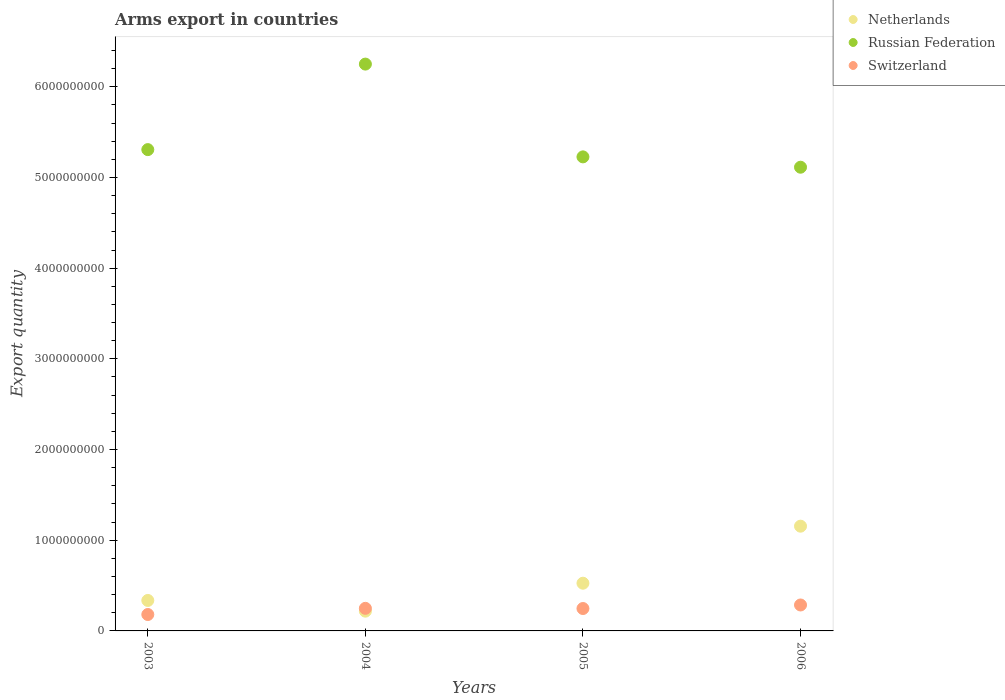What is the total arms export in Switzerland in 2005?
Ensure brevity in your answer.  2.47e+08. Across all years, what is the maximum total arms export in Switzerland?
Provide a short and direct response. 2.86e+08. Across all years, what is the minimum total arms export in Russian Federation?
Provide a succinct answer. 5.11e+09. In which year was the total arms export in Switzerland minimum?
Provide a short and direct response. 2003. What is the total total arms export in Russian Federation in the graph?
Offer a very short reply. 2.19e+1. What is the difference between the total arms export in Netherlands in 2004 and that in 2005?
Ensure brevity in your answer.  -3.08e+08. What is the difference between the total arms export in Netherlands in 2004 and the total arms export in Russian Federation in 2005?
Give a very brief answer. -5.01e+09. What is the average total arms export in Switzerland per year?
Make the answer very short. 2.41e+08. In the year 2004, what is the difference between the total arms export in Russian Federation and total arms export in Netherlands?
Make the answer very short. 6.03e+09. What is the ratio of the total arms export in Switzerland in 2004 to that in 2005?
Your response must be concise. 1.01. Is the difference between the total arms export in Russian Federation in 2003 and 2004 greater than the difference between the total arms export in Netherlands in 2003 and 2004?
Give a very brief answer. No. What is the difference between the highest and the second highest total arms export in Russian Federation?
Ensure brevity in your answer.  9.43e+08. What is the difference between the highest and the lowest total arms export in Netherlands?
Your answer should be compact. 9.37e+08. In how many years, is the total arms export in Russian Federation greater than the average total arms export in Russian Federation taken over all years?
Make the answer very short. 1. Is it the case that in every year, the sum of the total arms export in Switzerland and total arms export in Netherlands  is greater than the total arms export in Russian Federation?
Offer a terse response. No. Does the total arms export in Netherlands monotonically increase over the years?
Provide a short and direct response. No. How many dotlines are there?
Your answer should be very brief. 3. What is the difference between two consecutive major ticks on the Y-axis?
Your answer should be compact. 1.00e+09. Does the graph contain any zero values?
Offer a terse response. No. Does the graph contain grids?
Provide a short and direct response. No. How are the legend labels stacked?
Keep it short and to the point. Vertical. What is the title of the graph?
Offer a terse response. Arms export in countries. Does "Heavily indebted poor countries" appear as one of the legend labels in the graph?
Ensure brevity in your answer.  No. What is the label or title of the X-axis?
Your answer should be very brief. Years. What is the label or title of the Y-axis?
Provide a succinct answer. Export quantity. What is the Export quantity in Netherlands in 2003?
Make the answer very short. 3.36e+08. What is the Export quantity of Russian Federation in 2003?
Keep it short and to the point. 5.31e+09. What is the Export quantity of Switzerland in 2003?
Your answer should be compact. 1.81e+08. What is the Export quantity in Netherlands in 2004?
Give a very brief answer. 2.18e+08. What is the Export quantity of Russian Federation in 2004?
Ensure brevity in your answer.  6.25e+09. What is the Export quantity in Switzerland in 2004?
Your answer should be compact. 2.49e+08. What is the Export quantity of Netherlands in 2005?
Make the answer very short. 5.26e+08. What is the Export quantity of Russian Federation in 2005?
Make the answer very short. 5.23e+09. What is the Export quantity in Switzerland in 2005?
Your answer should be compact. 2.47e+08. What is the Export quantity in Netherlands in 2006?
Your response must be concise. 1.16e+09. What is the Export quantity in Russian Federation in 2006?
Your response must be concise. 5.11e+09. What is the Export quantity in Switzerland in 2006?
Your answer should be very brief. 2.86e+08. Across all years, what is the maximum Export quantity of Netherlands?
Provide a succinct answer. 1.16e+09. Across all years, what is the maximum Export quantity in Russian Federation?
Offer a terse response. 6.25e+09. Across all years, what is the maximum Export quantity in Switzerland?
Ensure brevity in your answer.  2.86e+08. Across all years, what is the minimum Export quantity of Netherlands?
Offer a terse response. 2.18e+08. Across all years, what is the minimum Export quantity of Russian Federation?
Keep it short and to the point. 5.11e+09. Across all years, what is the minimum Export quantity in Switzerland?
Offer a terse response. 1.81e+08. What is the total Export quantity in Netherlands in the graph?
Provide a succinct answer. 2.24e+09. What is the total Export quantity in Russian Federation in the graph?
Offer a very short reply. 2.19e+1. What is the total Export quantity in Switzerland in the graph?
Your answer should be compact. 9.63e+08. What is the difference between the Export quantity in Netherlands in 2003 and that in 2004?
Make the answer very short. 1.18e+08. What is the difference between the Export quantity of Russian Federation in 2003 and that in 2004?
Your answer should be very brief. -9.43e+08. What is the difference between the Export quantity in Switzerland in 2003 and that in 2004?
Your answer should be compact. -6.80e+07. What is the difference between the Export quantity of Netherlands in 2003 and that in 2005?
Ensure brevity in your answer.  -1.90e+08. What is the difference between the Export quantity in Russian Federation in 2003 and that in 2005?
Your response must be concise. 8.00e+07. What is the difference between the Export quantity in Switzerland in 2003 and that in 2005?
Keep it short and to the point. -6.60e+07. What is the difference between the Export quantity of Netherlands in 2003 and that in 2006?
Make the answer very short. -8.19e+08. What is the difference between the Export quantity of Russian Federation in 2003 and that in 2006?
Keep it short and to the point. 1.94e+08. What is the difference between the Export quantity in Switzerland in 2003 and that in 2006?
Offer a very short reply. -1.05e+08. What is the difference between the Export quantity in Netherlands in 2004 and that in 2005?
Your response must be concise. -3.08e+08. What is the difference between the Export quantity in Russian Federation in 2004 and that in 2005?
Provide a succinct answer. 1.02e+09. What is the difference between the Export quantity of Switzerland in 2004 and that in 2005?
Make the answer very short. 2.00e+06. What is the difference between the Export quantity in Netherlands in 2004 and that in 2006?
Ensure brevity in your answer.  -9.37e+08. What is the difference between the Export quantity in Russian Federation in 2004 and that in 2006?
Provide a short and direct response. 1.14e+09. What is the difference between the Export quantity in Switzerland in 2004 and that in 2006?
Keep it short and to the point. -3.70e+07. What is the difference between the Export quantity of Netherlands in 2005 and that in 2006?
Your answer should be very brief. -6.29e+08. What is the difference between the Export quantity of Russian Federation in 2005 and that in 2006?
Offer a very short reply. 1.14e+08. What is the difference between the Export quantity of Switzerland in 2005 and that in 2006?
Offer a very short reply. -3.90e+07. What is the difference between the Export quantity of Netherlands in 2003 and the Export quantity of Russian Federation in 2004?
Give a very brief answer. -5.91e+09. What is the difference between the Export quantity of Netherlands in 2003 and the Export quantity of Switzerland in 2004?
Provide a short and direct response. 8.70e+07. What is the difference between the Export quantity in Russian Federation in 2003 and the Export quantity in Switzerland in 2004?
Provide a succinct answer. 5.06e+09. What is the difference between the Export quantity in Netherlands in 2003 and the Export quantity in Russian Federation in 2005?
Keep it short and to the point. -4.89e+09. What is the difference between the Export quantity of Netherlands in 2003 and the Export quantity of Switzerland in 2005?
Ensure brevity in your answer.  8.90e+07. What is the difference between the Export quantity of Russian Federation in 2003 and the Export quantity of Switzerland in 2005?
Your answer should be very brief. 5.06e+09. What is the difference between the Export quantity of Netherlands in 2003 and the Export quantity of Russian Federation in 2006?
Keep it short and to the point. -4.78e+09. What is the difference between the Export quantity in Russian Federation in 2003 and the Export quantity in Switzerland in 2006?
Your answer should be very brief. 5.02e+09. What is the difference between the Export quantity in Netherlands in 2004 and the Export quantity in Russian Federation in 2005?
Your answer should be compact. -5.01e+09. What is the difference between the Export quantity in Netherlands in 2004 and the Export quantity in Switzerland in 2005?
Offer a very short reply. -2.90e+07. What is the difference between the Export quantity of Russian Federation in 2004 and the Export quantity of Switzerland in 2005?
Offer a very short reply. 6.00e+09. What is the difference between the Export quantity of Netherlands in 2004 and the Export quantity of Russian Federation in 2006?
Keep it short and to the point. -4.90e+09. What is the difference between the Export quantity in Netherlands in 2004 and the Export quantity in Switzerland in 2006?
Offer a very short reply. -6.80e+07. What is the difference between the Export quantity in Russian Federation in 2004 and the Export quantity in Switzerland in 2006?
Your response must be concise. 5.96e+09. What is the difference between the Export quantity of Netherlands in 2005 and the Export quantity of Russian Federation in 2006?
Give a very brief answer. -4.59e+09. What is the difference between the Export quantity in Netherlands in 2005 and the Export quantity in Switzerland in 2006?
Your answer should be compact. 2.40e+08. What is the difference between the Export quantity in Russian Federation in 2005 and the Export quantity in Switzerland in 2006?
Offer a very short reply. 4.94e+09. What is the average Export quantity of Netherlands per year?
Your answer should be very brief. 5.59e+08. What is the average Export quantity of Russian Federation per year?
Make the answer very short. 5.47e+09. What is the average Export quantity of Switzerland per year?
Provide a short and direct response. 2.41e+08. In the year 2003, what is the difference between the Export quantity in Netherlands and Export quantity in Russian Federation?
Your response must be concise. -4.97e+09. In the year 2003, what is the difference between the Export quantity in Netherlands and Export quantity in Switzerland?
Your answer should be very brief. 1.55e+08. In the year 2003, what is the difference between the Export quantity of Russian Federation and Export quantity of Switzerland?
Make the answer very short. 5.13e+09. In the year 2004, what is the difference between the Export quantity in Netherlands and Export quantity in Russian Federation?
Your answer should be compact. -6.03e+09. In the year 2004, what is the difference between the Export quantity of Netherlands and Export quantity of Switzerland?
Offer a very short reply. -3.10e+07. In the year 2004, what is the difference between the Export quantity of Russian Federation and Export quantity of Switzerland?
Ensure brevity in your answer.  6.00e+09. In the year 2005, what is the difference between the Export quantity of Netherlands and Export quantity of Russian Federation?
Ensure brevity in your answer.  -4.70e+09. In the year 2005, what is the difference between the Export quantity in Netherlands and Export quantity in Switzerland?
Ensure brevity in your answer.  2.79e+08. In the year 2005, what is the difference between the Export quantity in Russian Federation and Export quantity in Switzerland?
Give a very brief answer. 4.98e+09. In the year 2006, what is the difference between the Export quantity in Netherlands and Export quantity in Russian Federation?
Offer a very short reply. -3.96e+09. In the year 2006, what is the difference between the Export quantity in Netherlands and Export quantity in Switzerland?
Your answer should be very brief. 8.69e+08. In the year 2006, what is the difference between the Export quantity of Russian Federation and Export quantity of Switzerland?
Provide a short and direct response. 4.83e+09. What is the ratio of the Export quantity of Netherlands in 2003 to that in 2004?
Your answer should be very brief. 1.54. What is the ratio of the Export quantity of Russian Federation in 2003 to that in 2004?
Your answer should be compact. 0.85. What is the ratio of the Export quantity in Switzerland in 2003 to that in 2004?
Your response must be concise. 0.73. What is the ratio of the Export quantity of Netherlands in 2003 to that in 2005?
Make the answer very short. 0.64. What is the ratio of the Export quantity in Russian Federation in 2003 to that in 2005?
Your answer should be very brief. 1.02. What is the ratio of the Export quantity of Switzerland in 2003 to that in 2005?
Offer a very short reply. 0.73. What is the ratio of the Export quantity of Netherlands in 2003 to that in 2006?
Make the answer very short. 0.29. What is the ratio of the Export quantity in Russian Federation in 2003 to that in 2006?
Give a very brief answer. 1.04. What is the ratio of the Export quantity of Switzerland in 2003 to that in 2006?
Your answer should be compact. 0.63. What is the ratio of the Export quantity in Netherlands in 2004 to that in 2005?
Your answer should be compact. 0.41. What is the ratio of the Export quantity of Russian Federation in 2004 to that in 2005?
Make the answer very short. 1.2. What is the ratio of the Export quantity of Netherlands in 2004 to that in 2006?
Your answer should be compact. 0.19. What is the ratio of the Export quantity of Russian Federation in 2004 to that in 2006?
Your answer should be very brief. 1.22. What is the ratio of the Export quantity of Switzerland in 2004 to that in 2006?
Your answer should be compact. 0.87. What is the ratio of the Export quantity in Netherlands in 2005 to that in 2006?
Make the answer very short. 0.46. What is the ratio of the Export quantity of Russian Federation in 2005 to that in 2006?
Make the answer very short. 1.02. What is the ratio of the Export quantity in Switzerland in 2005 to that in 2006?
Keep it short and to the point. 0.86. What is the difference between the highest and the second highest Export quantity of Netherlands?
Ensure brevity in your answer.  6.29e+08. What is the difference between the highest and the second highest Export quantity in Russian Federation?
Provide a short and direct response. 9.43e+08. What is the difference between the highest and the second highest Export quantity of Switzerland?
Provide a short and direct response. 3.70e+07. What is the difference between the highest and the lowest Export quantity in Netherlands?
Ensure brevity in your answer.  9.37e+08. What is the difference between the highest and the lowest Export quantity of Russian Federation?
Your answer should be very brief. 1.14e+09. What is the difference between the highest and the lowest Export quantity of Switzerland?
Your response must be concise. 1.05e+08. 